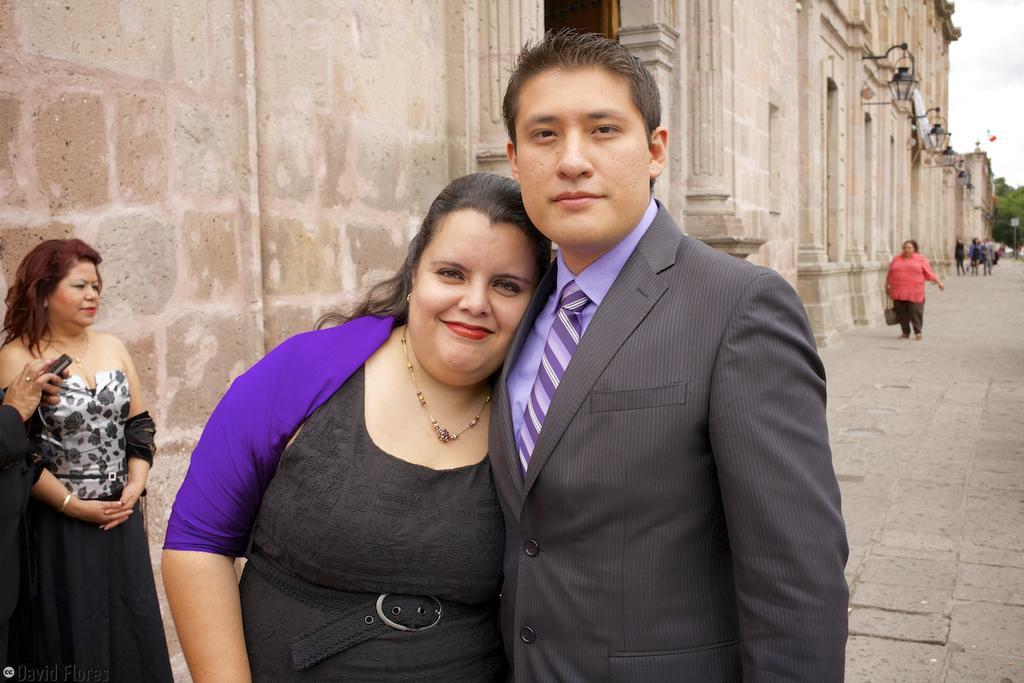Describe this image in one or two sentences. In this image, we can see few people. Here we can see a woman and man are seeing and smiling. Background there is a walls and lights. Right side of the image, we can see trees and sky. 